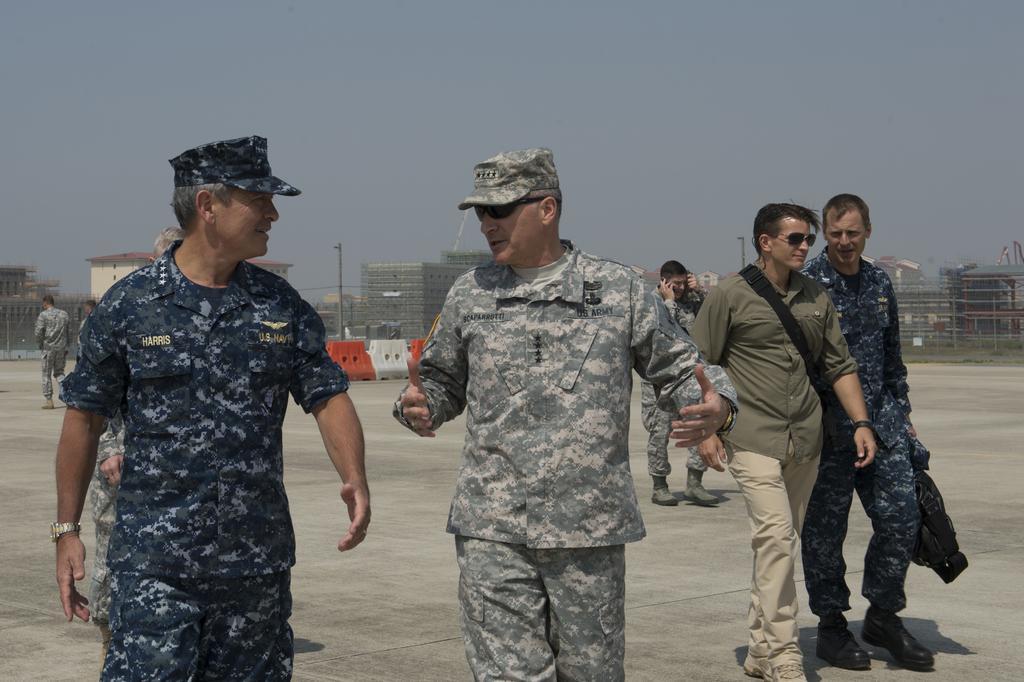Can you describe this image briefly? In this image, we can see persons wearing clothes. There are some buildings in the middle of the image. In the background of the image, there is a sky. 